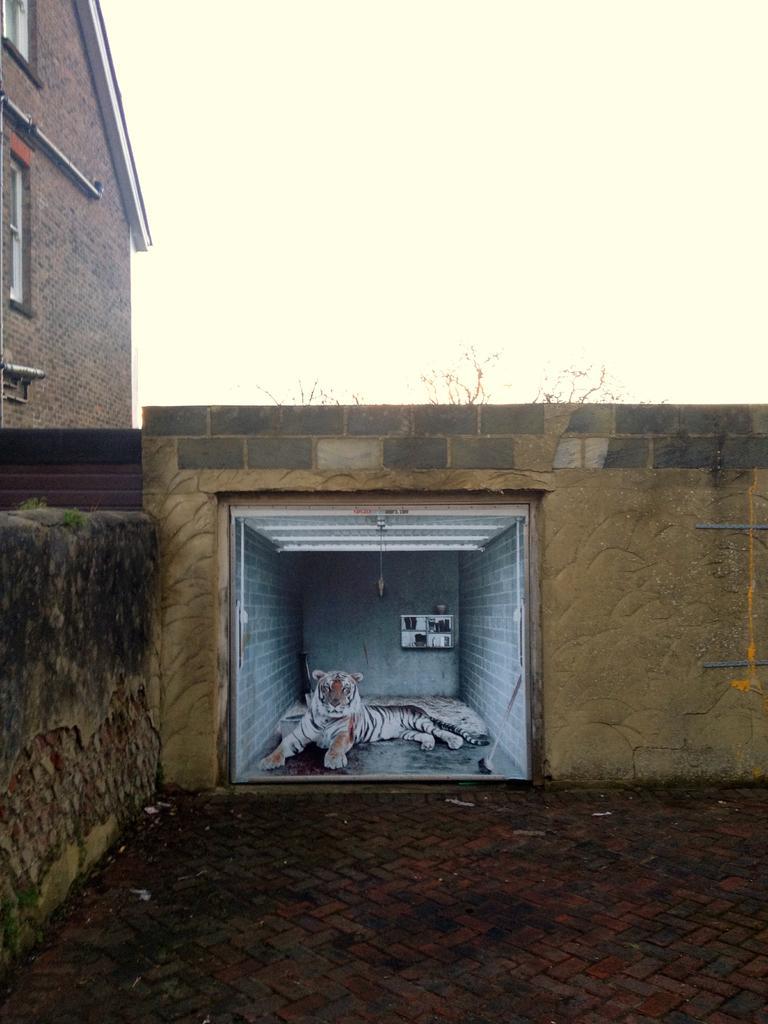Could you give a brief overview of what you see in this image? In the middle of the image we can see a tiger in the room, in the background we can see a building and tree branches. 